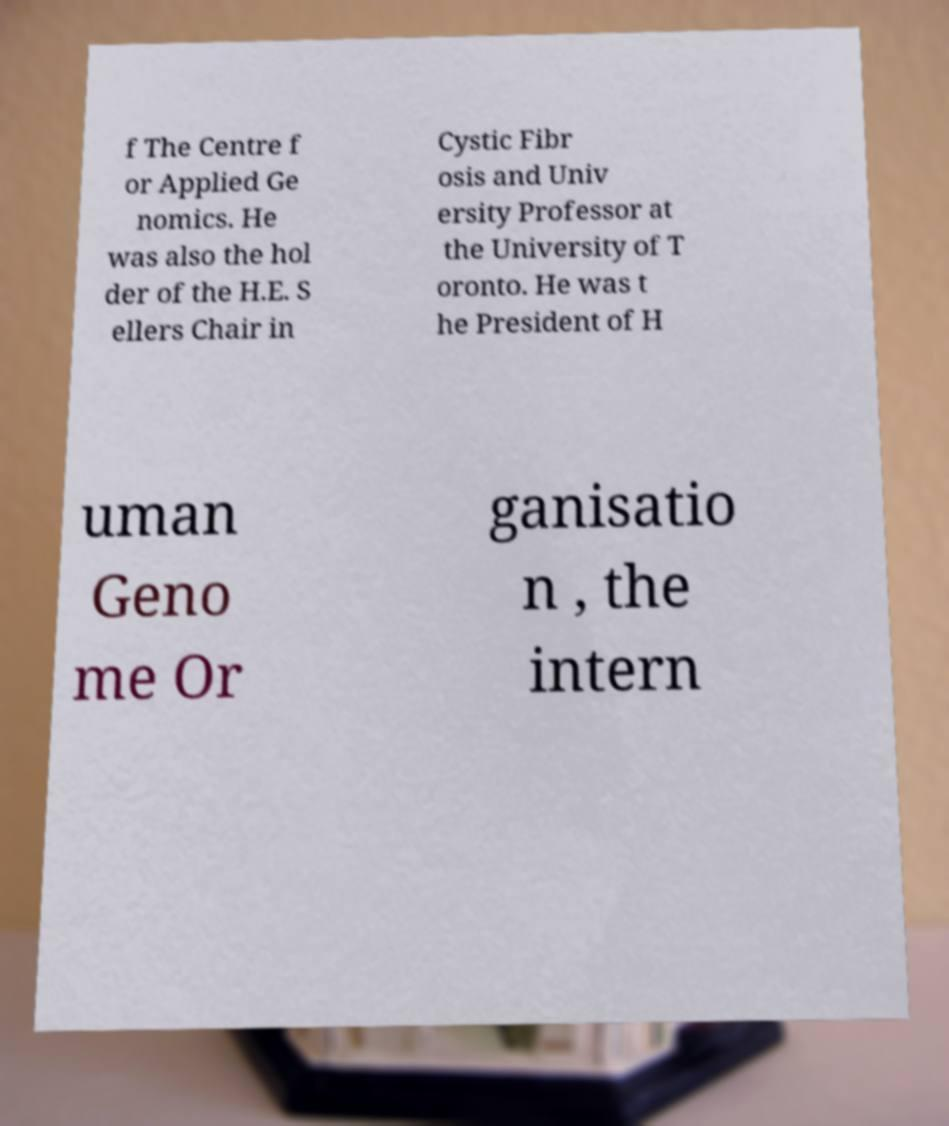Could you assist in decoding the text presented in this image and type it out clearly? f The Centre f or Applied Ge nomics. He was also the hol der of the H.E. S ellers Chair in Cystic Fibr osis and Univ ersity Professor at the University of T oronto. He was t he President of H uman Geno me Or ganisatio n , the intern 